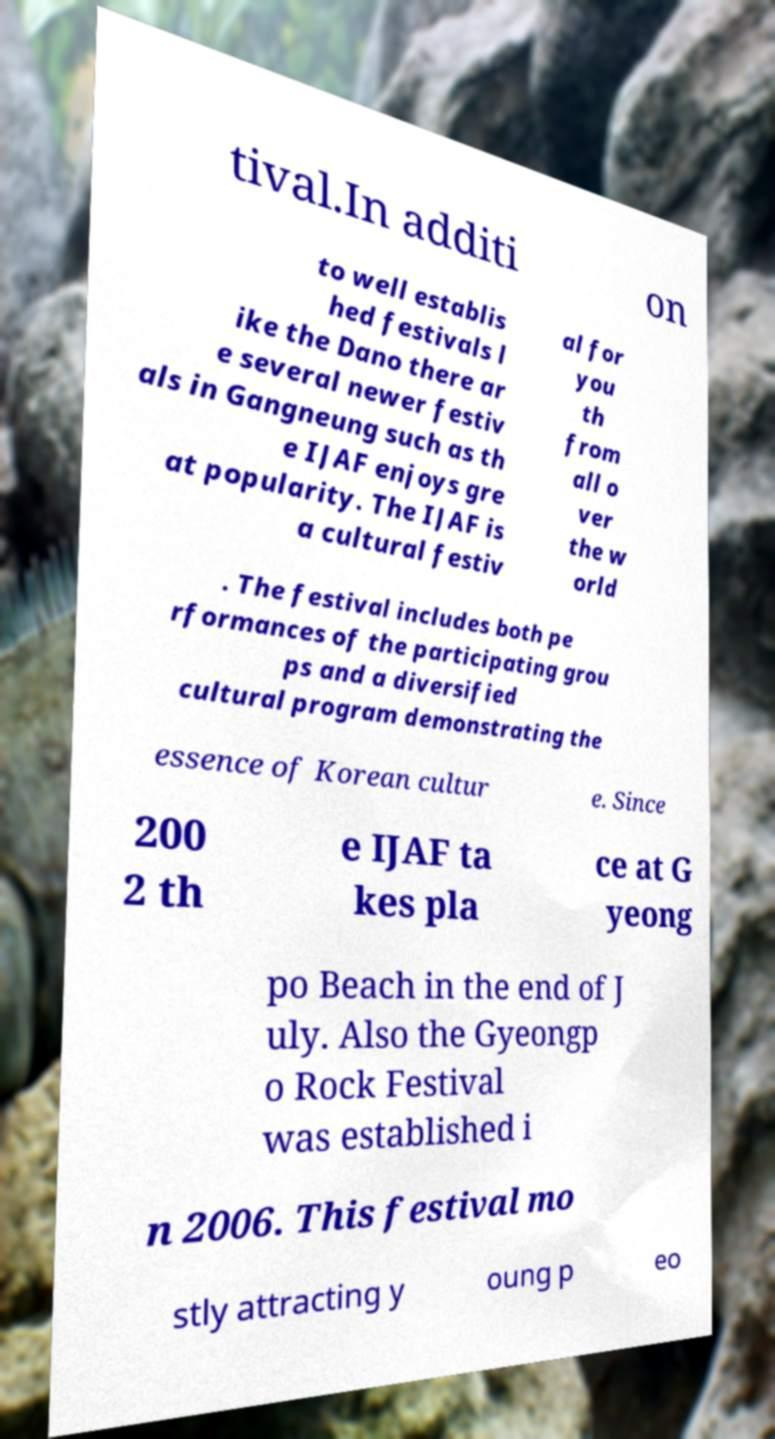What messages or text are displayed in this image? I need them in a readable, typed format. tival.In additi on to well establis hed festivals l ike the Dano there ar e several newer festiv als in Gangneung such as th e IJAF enjoys gre at popularity. The IJAF is a cultural festiv al for you th from all o ver the w orld . The festival includes both pe rformances of the participating grou ps and a diversified cultural program demonstrating the essence of Korean cultur e. Since 200 2 th e IJAF ta kes pla ce at G yeong po Beach in the end of J uly. Also the Gyeongp o Rock Festival was established i n 2006. This festival mo stly attracting y oung p eo 